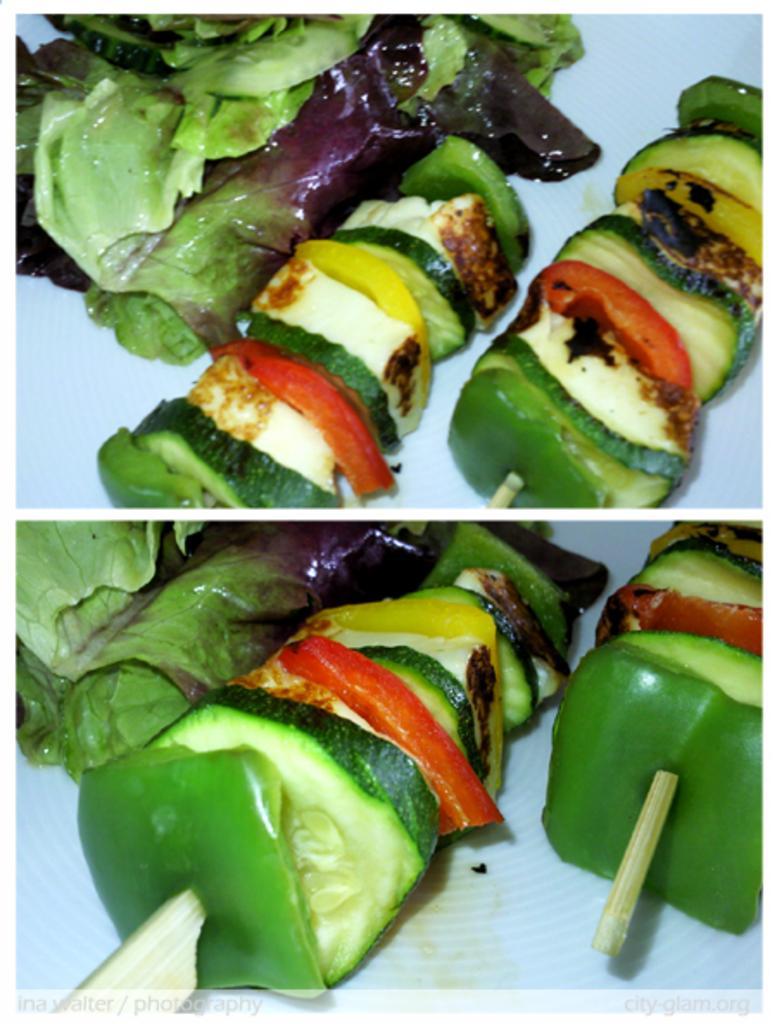In one or two sentences, can you explain what this image depicts? In this image we can see a collage of a picture in which group of food items is placed on a stick. 